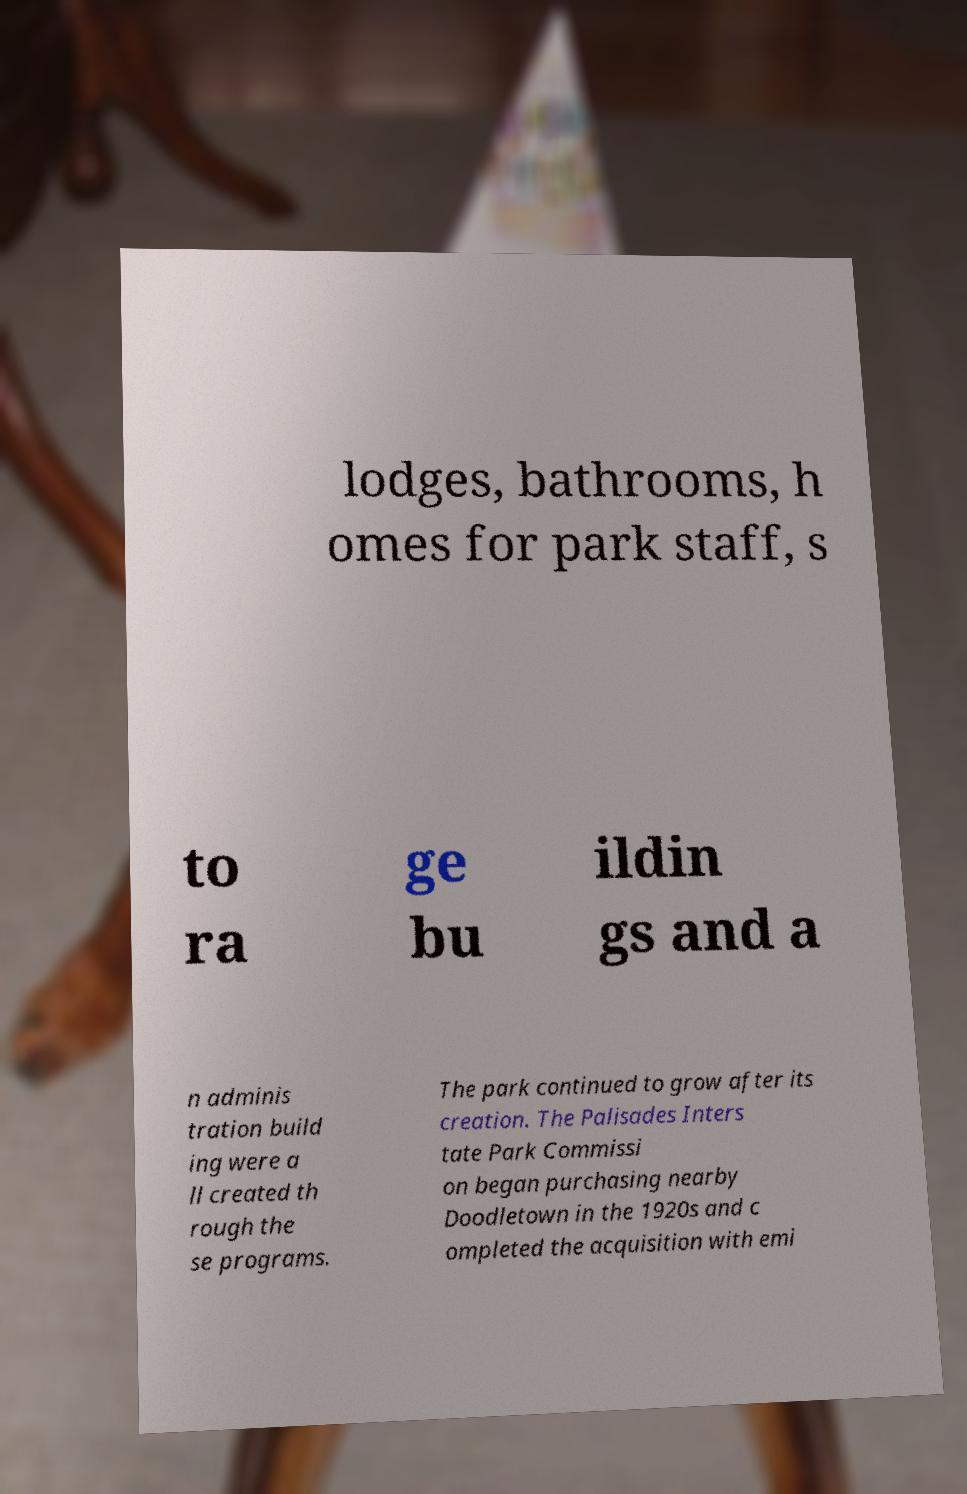Could you extract and type out the text from this image? lodges, bathrooms, h omes for park staff, s to ra ge bu ildin gs and a n adminis tration build ing were a ll created th rough the se programs. The park continued to grow after its creation. The Palisades Inters tate Park Commissi on began purchasing nearby Doodletown in the 1920s and c ompleted the acquisition with emi 